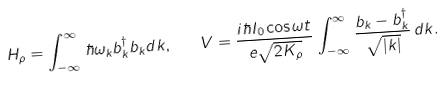Convert formula to latex. <formula><loc_0><loc_0><loc_500><loc_500>H _ { \rho } = \int _ { - \infty } ^ { \infty } \, \hbar { \omega } _ { k } b _ { k } ^ { \dagger } b _ { k } d k , \quad V = \frac { i \hbar { I } _ { 0 } \cos \omega t } { e \sqrt { 2 K _ { \rho } } } \int _ { - \infty } ^ { \infty } \, \frac { b _ { k } - b _ { k } ^ { \dagger } } { \sqrt { | k | } } \, d k .</formula> 